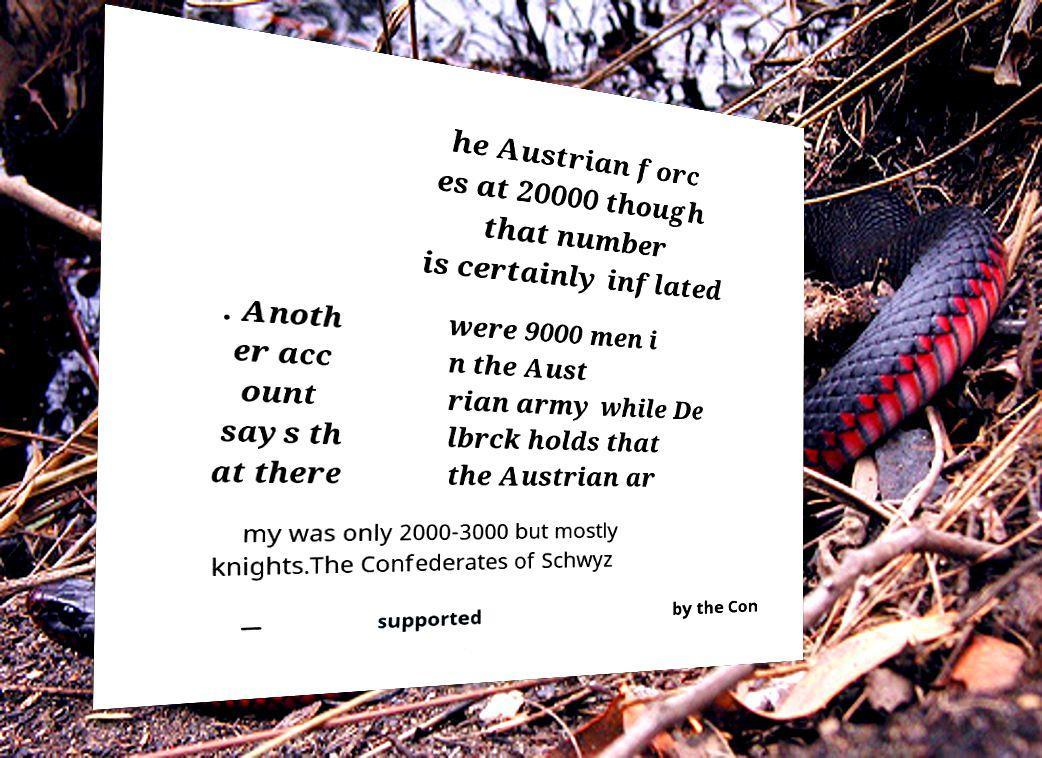Can you read and provide the text displayed in the image?This photo seems to have some interesting text. Can you extract and type it out for me? he Austrian forc es at 20000 though that number is certainly inflated . Anoth er acc ount says th at there were 9000 men i n the Aust rian army while De lbrck holds that the Austrian ar my was only 2000-3000 but mostly knights.The Confederates of Schwyz — supported by the Con 